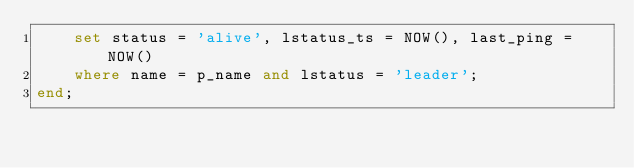Convert code to text. <code><loc_0><loc_0><loc_500><loc_500><_SQL_>    set status = 'alive', lstatus_ts = NOW(), last_ping = NOW()
    where name = p_name and lstatus = 'leader';
end;
</code> 